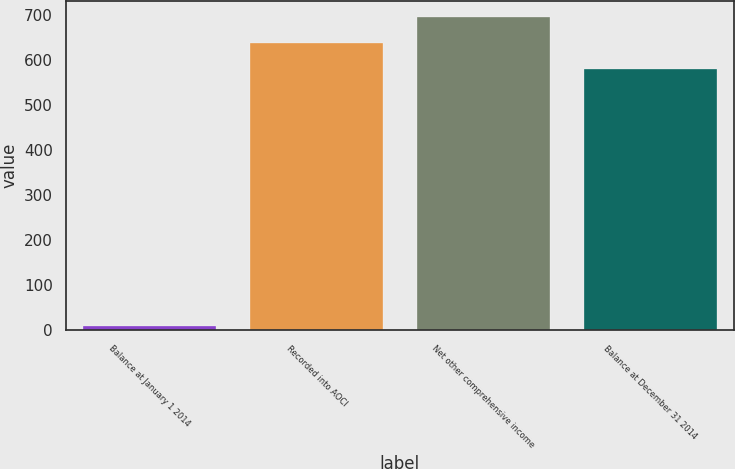Convert chart. <chart><loc_0><loc_0><loc_500><loc_500><bar_chart><fcel>Balance at January 1 2014<fcel>Recorded into AOCI<fcel>Net other comprehensive income<fcel>Balance at December 31 2014<nl><fcel>8.7<fcel>637.78<fcel>695.76<fcel>579.8<nl></chart> 